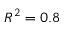<formula> <loc_0><loc_0><loc_500><loc_500>R ^ { 2 } = 0 . 8</formula> 